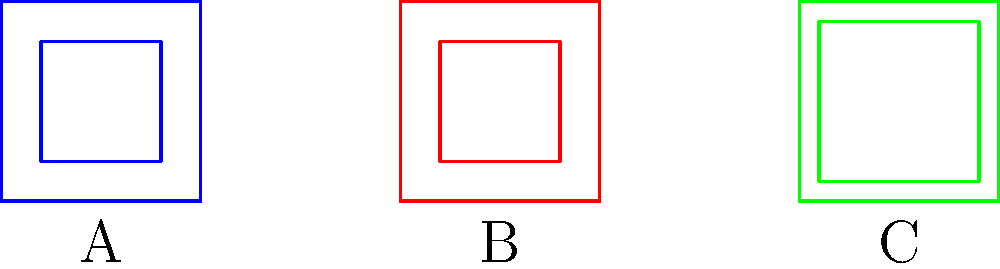In traditional Houma textiles, which two patterns shown above are congruent? To determine which patterns are congruent, we need to examine their shapes and sizes:

1. Pattern A (blue):
   - Outer square: 1 unit × 1 unit
   - Inner square: 0.6 unit × 0.6 unit (centered)

2. Pattern B (red):
   - Outer square: 1 unit × 1 unit
   - Inner square: 0.6 unit × 0.6 unit (centered)

3. Pattern C (green):
   - Outer square: 1 unit × 1 unit
   - Inner square: 0.8 unit × 0.8 unit (centered)

Congruent shapes have the same size and shape. Comparing the patterns:

- Patterns A and B have identical dimensions for both outer and inner squares.
- Pattern C has the same outer square but a larger inner square.

Therefore, patterns A and B are congruent to each other, while pattern C is different.
Answer: A and B 